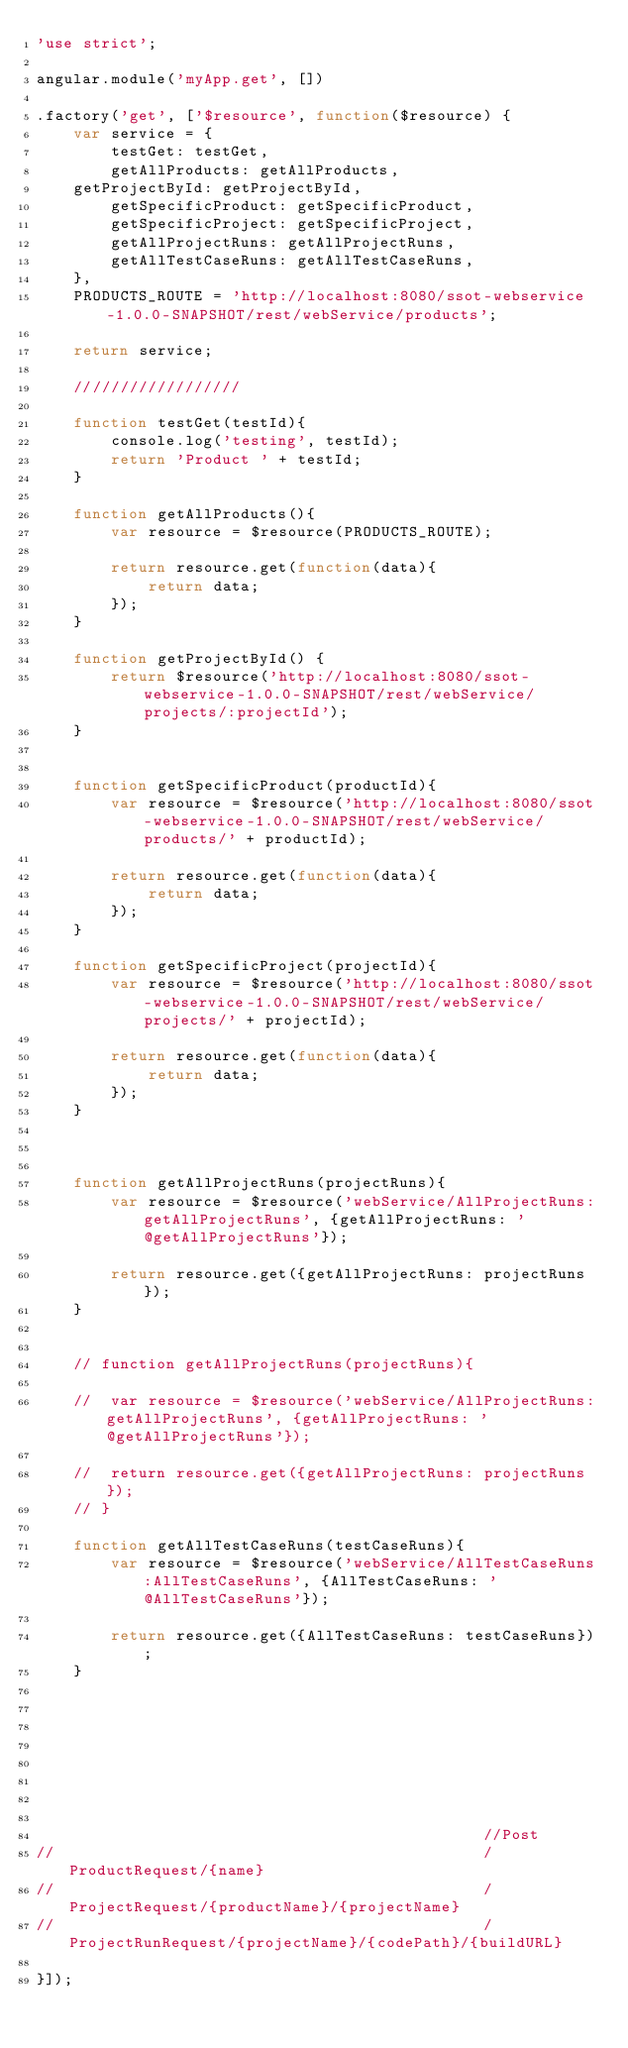Convert code to text. <code><loc_0><loc_0><loc_500><loc_500><_JavaScript_>'use strict';

angular.module('myApp.get', [])

.factory('get', ['$resource', function($resource) {
	var service = {
		testGet: testGet,
		getAllProducts: getAllProducts,
    getProjectById: getProjectById,
		getSpecificProduct: getSpecificProduct,
		getSpecificProject: getSpecificProject,
		getAllProjectRuns: getAllProjectRuns,
		getAllTestCaseRuns: getAllTestCaseRuns,
	},
	PRODUCTS_ROUTE = 'http://localhost:8080/ssot-webservice-1.0.0-SNAPSHOT/rest/webService/products';
	
	return service;
	
	//////////////////

	function testGet(testId){
		console.log('testing', testId);
		return 'Product ' + testId;
	}
	
	function getAllProducts(){
		var resource = $resource(PRODUCTS_ROUTE);
		
 		return resource.get(function(data){
	 		return data;
		});
	}

	function getProjectById() {
		return $resource('http://localhost:8080/ssot-webservice-1.0.0-SNAPSHOT/rest/webService/projects/:projectId');
	}

												
	function getSpecificProduct(productId){
		var resource = $resource('http://localhost:8080/ssot-webservice-1.0.0-SNAPSHOT/rest/webService/products/' + productId);

 		return resource.get(function(data){
	 		return data;
		});
	}

	function getSpecificProject(projectId){
		var resource = $resource('http://localhost:8080/ssot-webservice-1.0.0-SNAPSHOT/rest/webService/projects/' + projectId);

 		return resource.get(function(data){
	 		return data;
		});
	}

	
	
	function getAllProjectRuns(projectRuns){
		var resource = $resource('webService/AllProjectRuns:getAllProjectRuns', {getAllProjectRuns: '@getAllProjectRuns'});

		return resource.get({getAllProjectRuns: projectRuns});
	}			
																			
												
	// function getAllProjectRuns(projectRuns){
		
	// 	var resource = $resource('webService/AllProjectRuns:getAllProjectRuns', {getAllProjectRuns: '@getAllProjectRuns'});

	// 	return resource.get({getAllProjectRuns: projectRuns});
	// }	
		
	function getAllTestCaseRuns(testCaseRuns){
		var resource = $resource('webService/AllTestCaseRuns:AllTestCaseRuns', {AllTestCaseRuns: '@AllTestCaseRuns'});

		return resource.get({AllTestCaseRuns: testCaseRuns});
	}	
		

												
		
												
												
												
												
												//Post
//												/ProductRequest/{name}
//												/ProjectRequest/{productName}/{projectName}
//												/ProjectRunRequest/{projectName}/{codePath}/{buildURL}
												
}]);</code> 